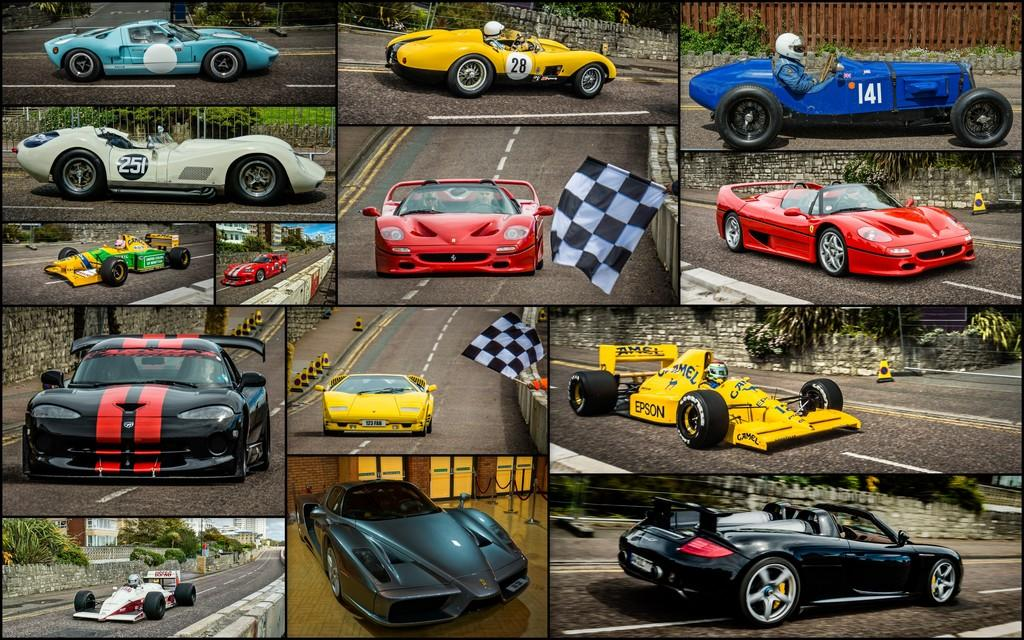What is the main subject of the image? The main subject of the image is a collage of cars. Can you describe the collage in more detail? The collage includes different types of cars. What year was the crow born in the image? There is no crow present in the image, so it is not possible to determine the year of its birth. 